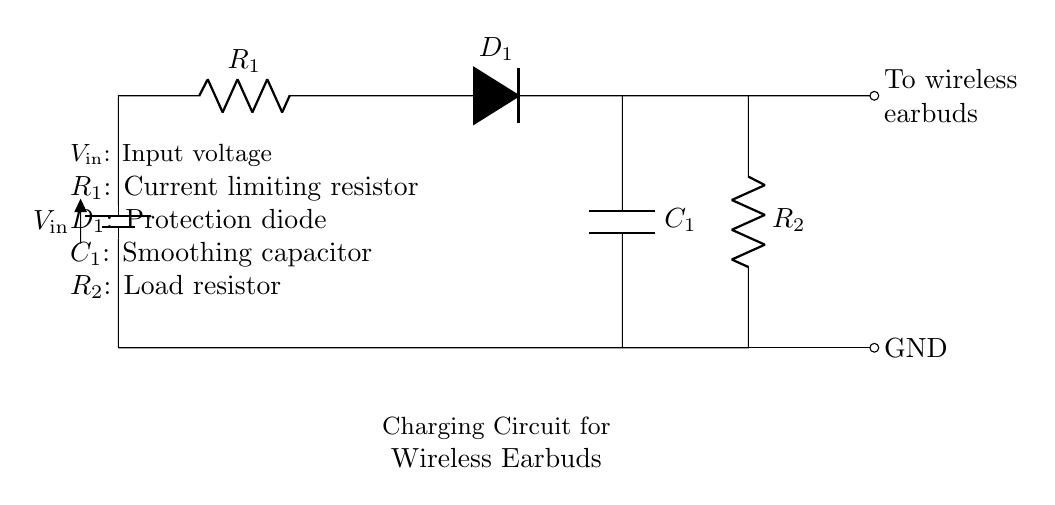What is the input voltage of the circuit? The input voltage, denoted as V_in, is specified in the circuit. It is the source voltage that powers the charging circuit.
Answer: V_in What does the resistor R_1 do? Resistor R_1 is identified as the current limiting resistor. Its role is to restrict the amount of current flowing into the circuit to protect the components from excessive current.
Answer: Current limiting resistor Where is the protection diode located? The protection diode D_1 is positioned on the circuit diagram between R_1 and C_1, specifically at the top of the circuit. Its purpose is to prevent reverse current that could damage the circuit.
Answer: Between R_1 and C_1 How many resistors are present in the circuit? There are two resistors present in the circuit, labeled R_1 and R_2. They serve different functions, with R_1 limiting current and R_2 acting as a load resistor.
Answer: Two What is the function of capacitor C_1? Capacitor C_1 is indicated in the circuit as a smoothing capacitor. Its function is to smooth out the voltage fluctuations and provide a steady voltage to the wireless earbuds during charging.
Answer: Smoothing capacitor What does the output of the circuit connect to? The output of the circuit connects to the wireless earbuds, allowing them to receive the charging current generated by the circuit.
Answer: Wireless earbuds What is the purpose of the load resistor R_2? Load resistor R_2 is used to simulate a load in the circuit, which represents the power consumption of the wireless earbuds being charged. It helps in controlling the output characteristics of the circuit.
Answer: Load resistor 